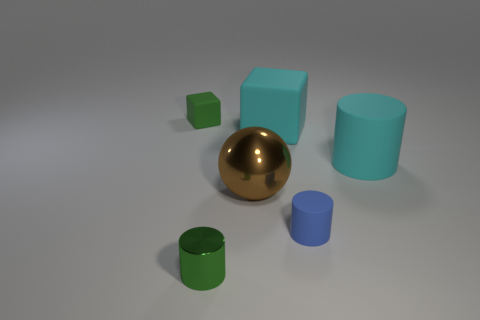Add 2 spheres. How many objects exist? 8 Subtract all spheres. How many objects are left? 5 Add 3 metallic cylinders. How many metallic cylinders are left? 4 Add 3 red matte things. How many red matte things exist? 3 Subtract 0 purple spheres. How many objects are left? 6 Subtract all tiny green blocks. Subtract all tiny objects. How many objects are left? 2 